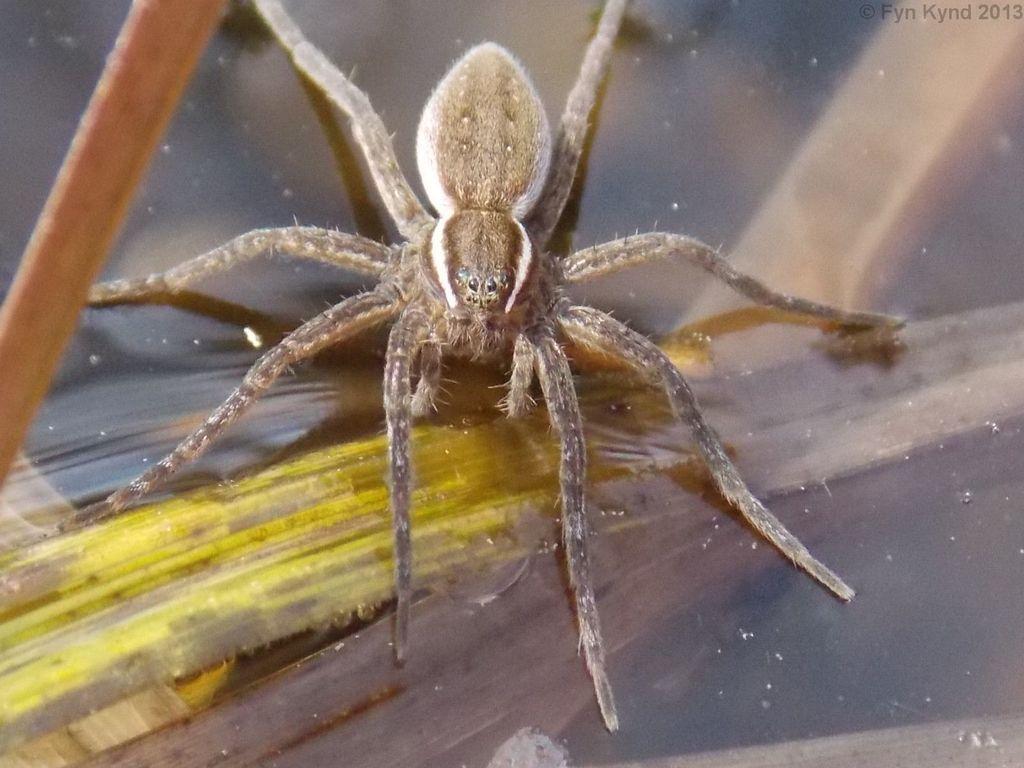In one or two sentences, can you explain what this image depicts? In this picture we can see spider in the glass. Here we can see glass table. 